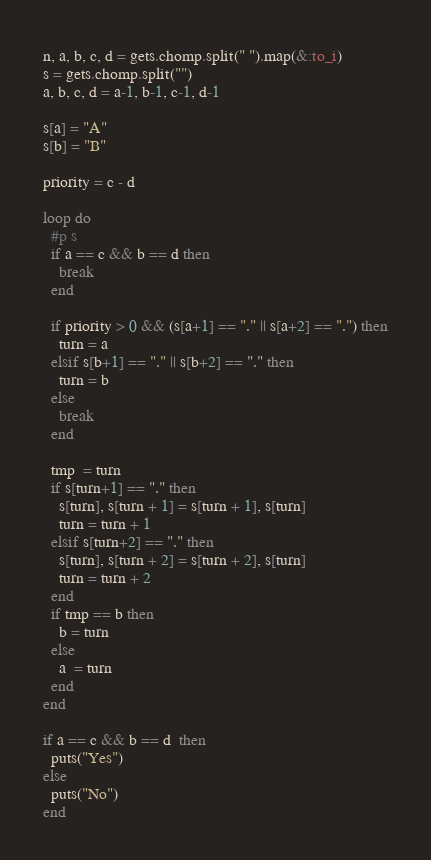Convert code to text. <code><loc_0><loc_0><loc_500><loc_500><_Ruby_>n, a, b, c, d = gets.chomp.split(" ").map(&:to_i)
s = gets.chomp.split("")
a, b, c, d = a-1, b-1, c-1, d-1

s[a] = "A"
s[b] = "B"

priority = c - d

loop do
  #p s
  if a == c && b == d then
    break
  end

  if priority > 0 && (s[a+1] == "." || s[a+2] == ".") then
    turn = a
  elsif s[b+1] == "." || s[b+2] == "." then
    turn = b
  else
    break
  end

  tmp  = turn
  if s[turn+1] == "." then
    s[turn], s[turn + 1] = s[turn + 1], s[turn] 
    turn = turn + 1
  elsif s[turn+2] == "." then
    s[turn], s[turn + 2] = s[turn + 2], s[turn] 
    turn = turn + 2
  end
  if tmp == b then
    b = turn
  else
    a  = turn
  end
end

if a == c && b == d  then
  puts("Yes")
else
  puts("No")
end</code> 